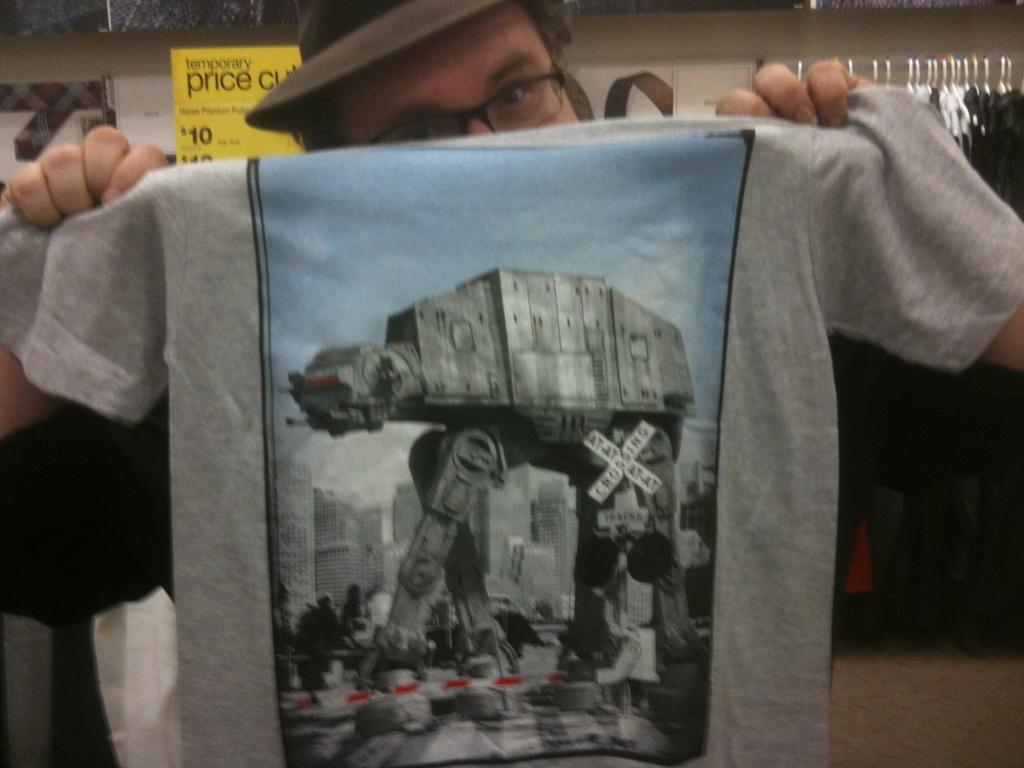Who is present in the image? There is a man in the image. What is the man holding in the image? The man is holding a T-shirt. What can be seen in the background of the image? There are clothes hanged in the background. What is the color of the price board in the image? The price board is yellow in color. What type of wood is used to make the party decorations in the image? There is no party or wood present in the image; it features a man holding a T-shirt, clothes in the background, and a yellow price board. 